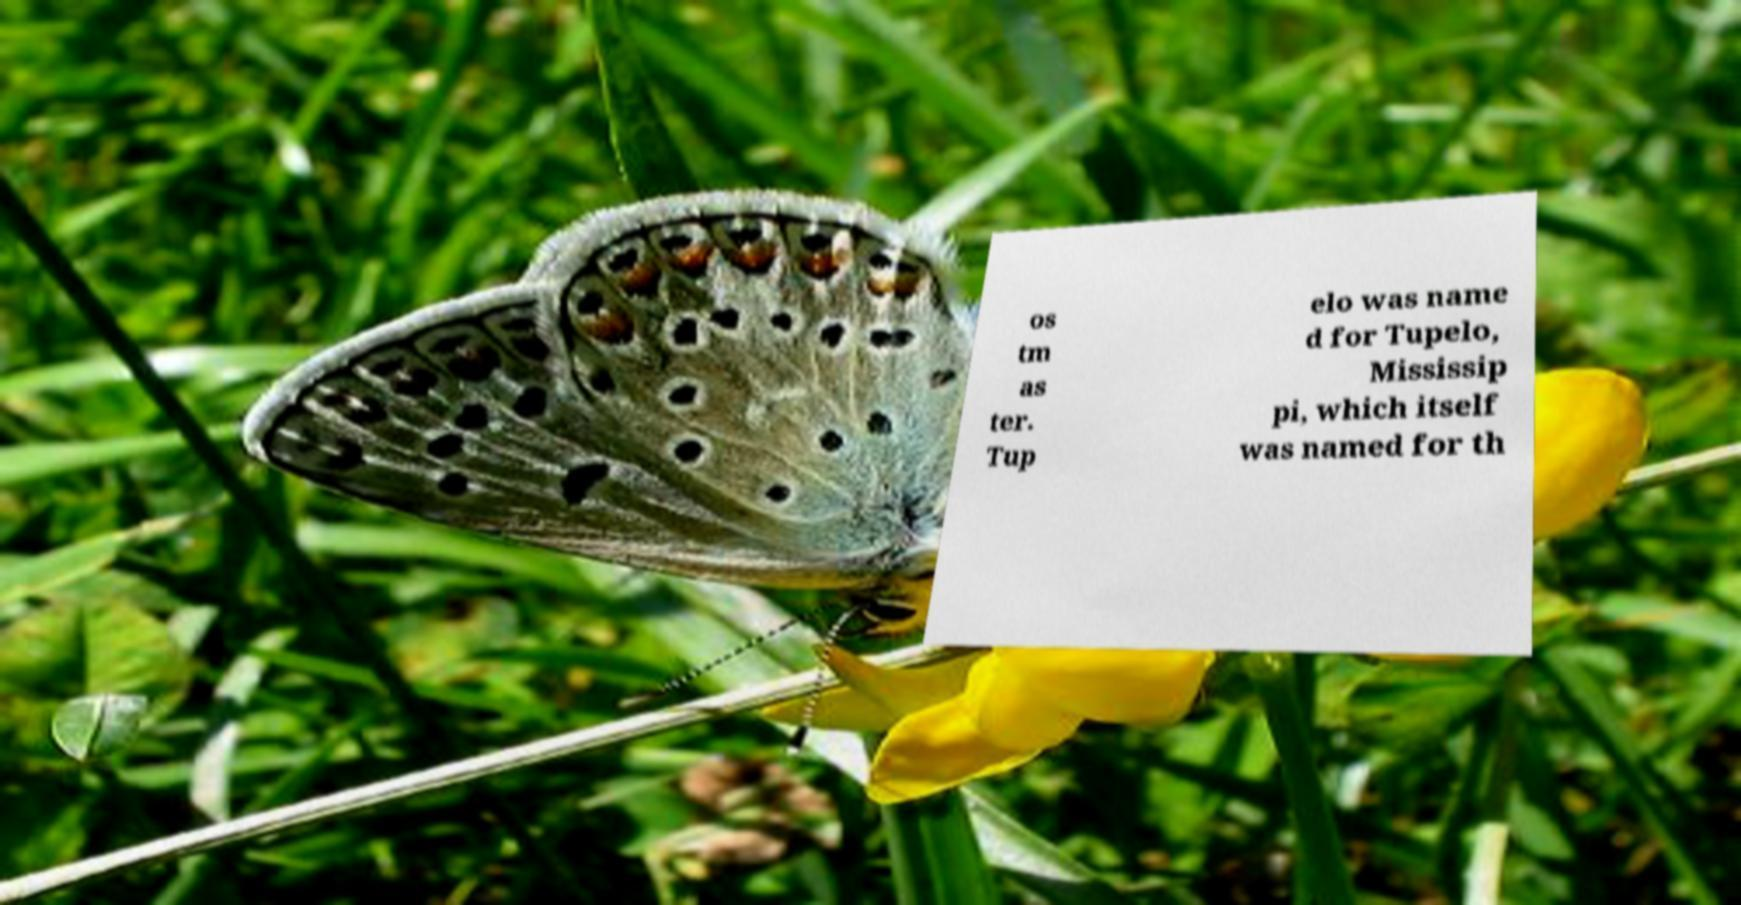Can you accurately transcribe the text from the provided image for me? os tm as ter. Tup elo was name d for Tupelo, Mississip pi, which itself was named for th 